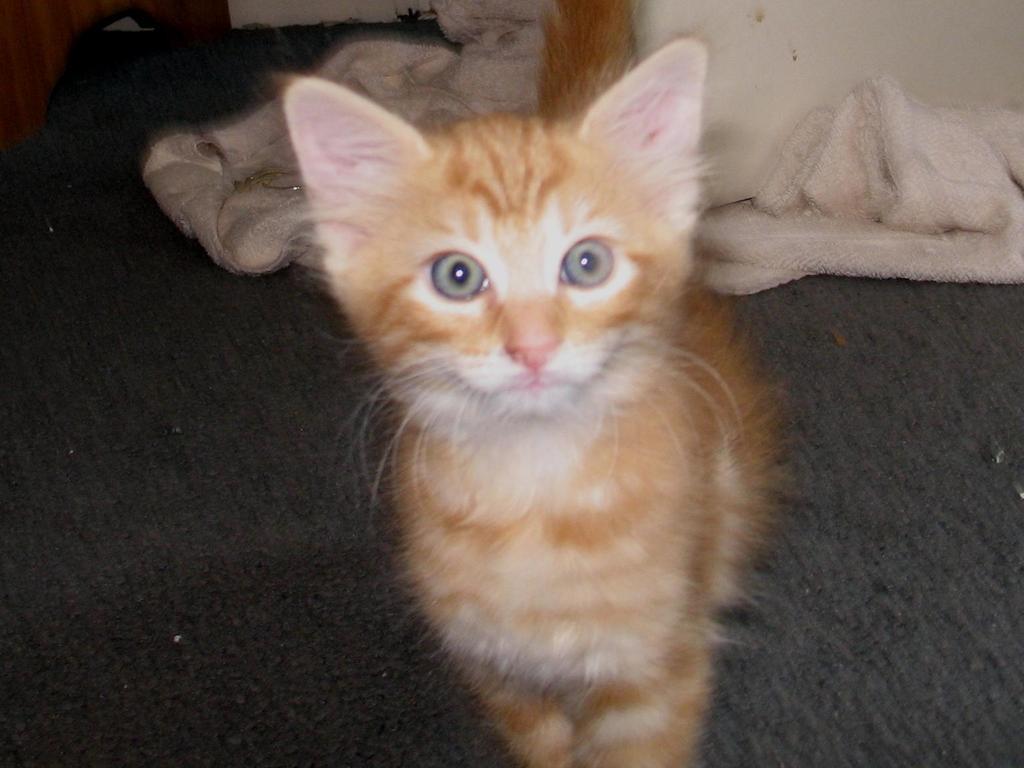Can you describe this image briefly? It is a cat which is in brown color, in the right side it's a cloth which is in white color. 